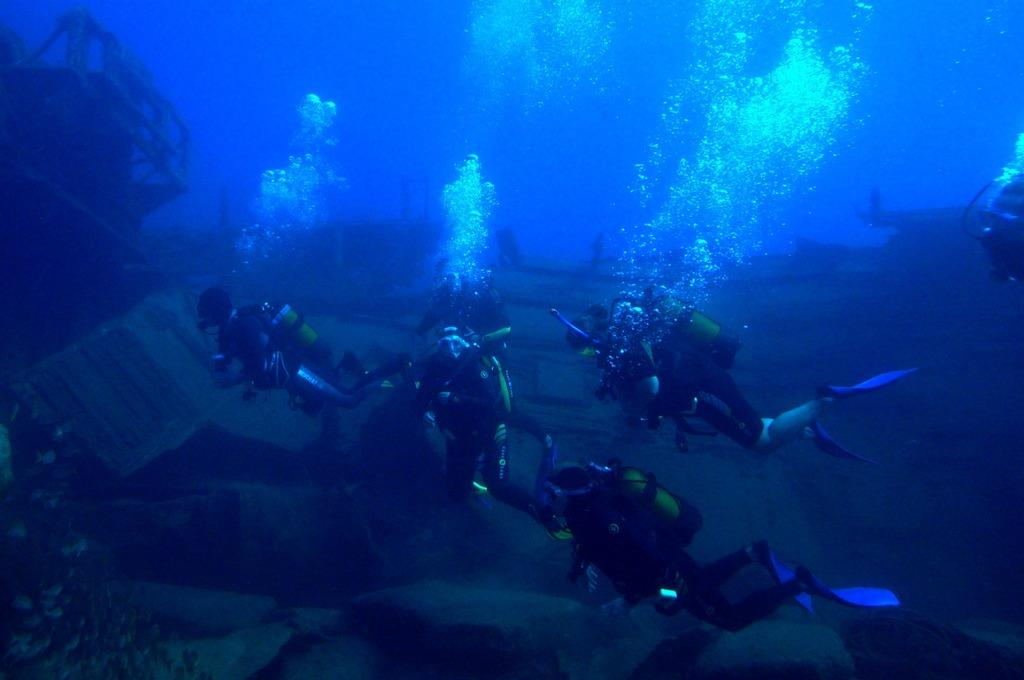How many people are in the image? There are persons in the image. What is the setting or environment in which the persons are located? The persons are under water. What type of metal is being pulled by the persons in the image? There is no metal present in the image, as the persons are under water and not interacting with any metal objects. 